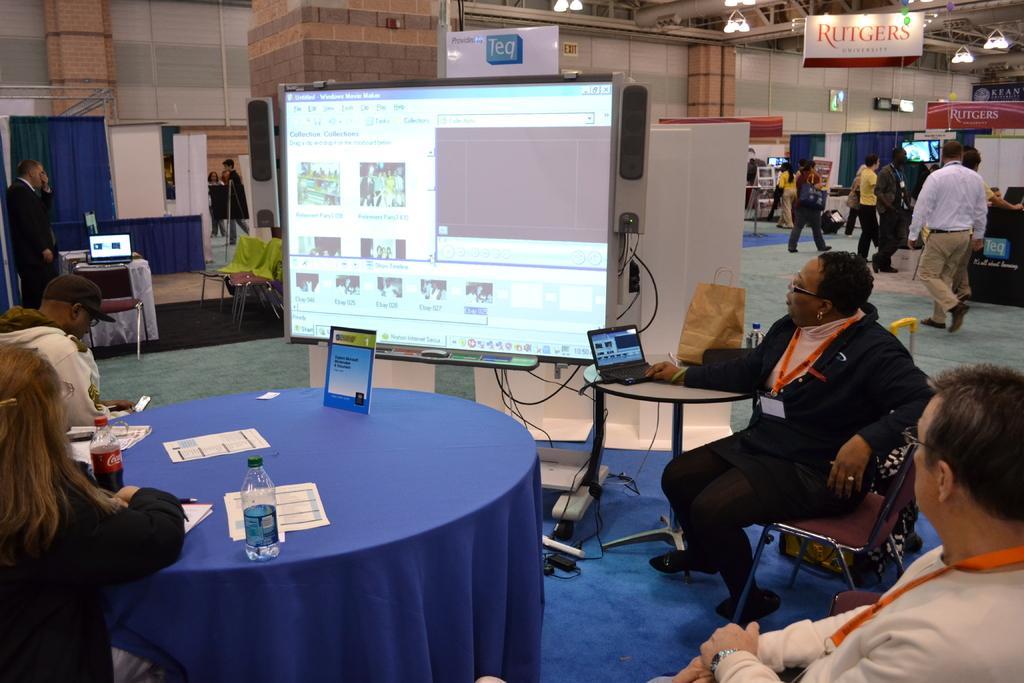Could you give a brief overview of what you see in this image? There is a group of people. Some people are sitting on a chairs. Some people are standing. There is a table. There is a bottle,poster,paper on a table. We can see in background curtain,projector and poster. 